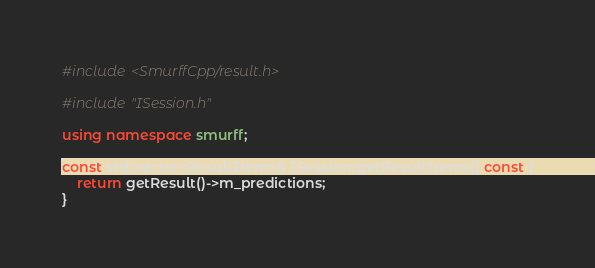Convert code to text. <code><loc_0><loc_0><loc_500><loc_500><_C++_>#include <SmurffCpp/result.h>

#include "ISession.h"

using namespace smurff;

const std::vector<ResultItem>& ISession::getResultItems() const {
    return getResult()->m_predictions;
}
</code> 